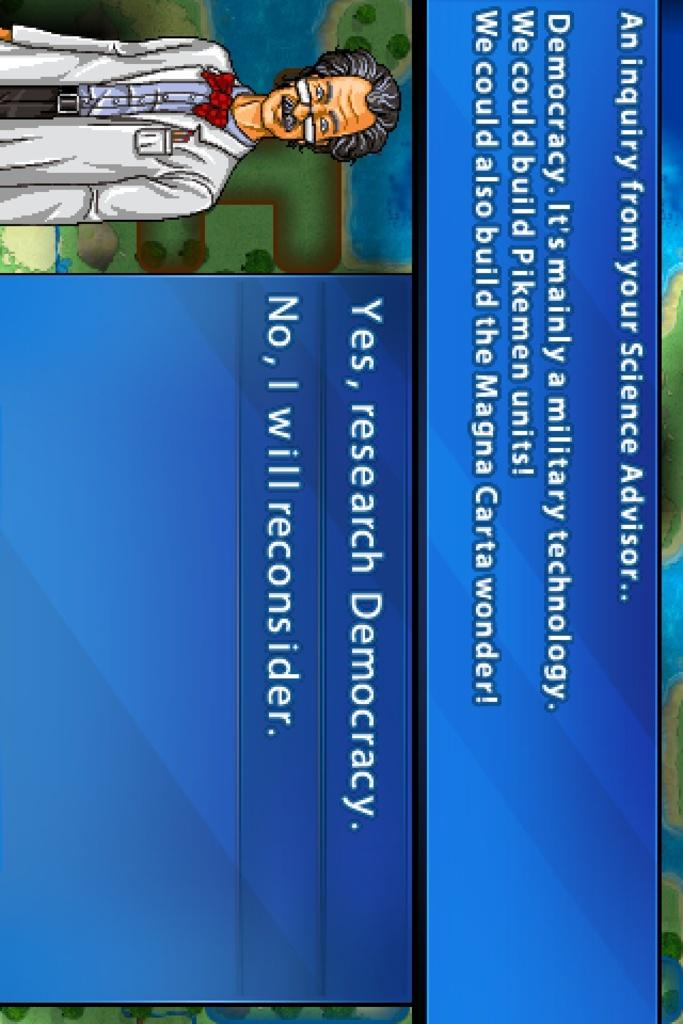What is the main subject of the image? The main subject of the image is a man standing. What else can be seen in the image besides the man? There is text present in the image. What day of the week is indicated on the calendar in the image? There is no calendar present in the image. What type of meal is being served by the servant in the image? There is no servant or meal present in the image. 